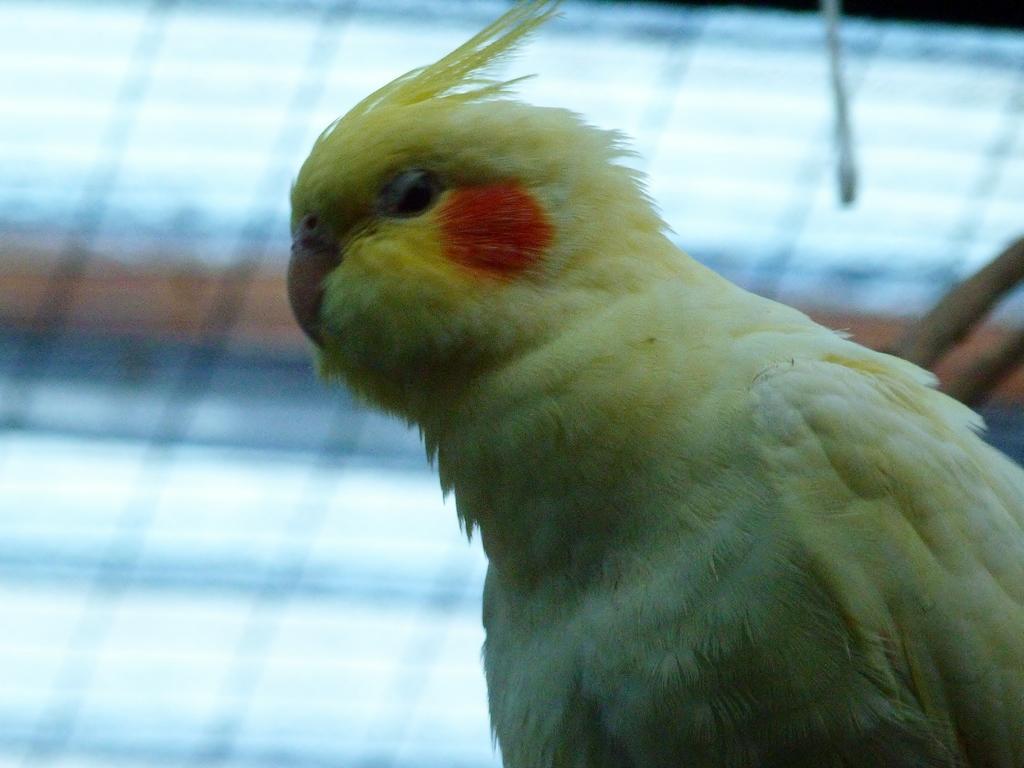How would you summarize this image in a sentence or two? In this image, on the right side, we can see a bird. In the background, we can see a net fence. 